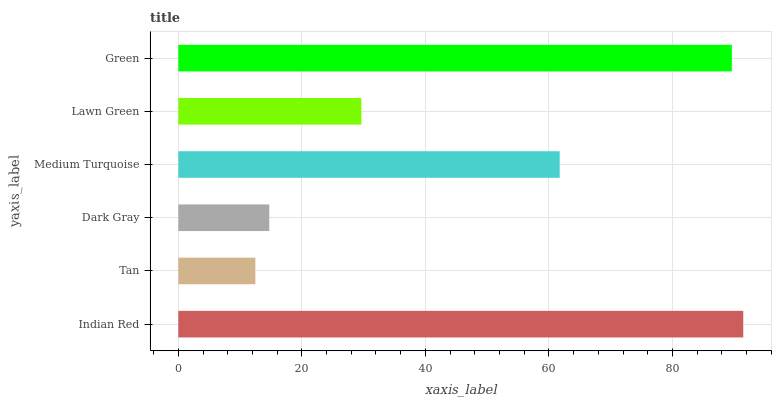Is Tan the minimum?
Answer yes or no. Yes. Is Indian Red the maximum?
Answer yes or no. Yes. Is Dark Gray the minimum?
Answer yes or no. No. Is Dark Gray the maximum?
Answer yes or no. No. Is Dark Gray greater than Tan?
Answer yes or no. Yes. Is Tan less than Dark Gray?
Answer yes or no. Yes. Is Tan greater than Dark Gray?
Answer yes or no. No. Is Dark Gray less than Tan?
Answer yes or no. No. Is Medium Turquoise the high median?
Answer yes or no. Yes. Is Lawn Green the low median?
Answer yes or no. Yes. Is Green the high median?
Answer yes or no. No. Is Green the low median?
Answer yes or no. No. 